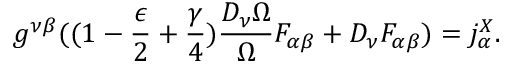Convert formula to latex. <formula><loc_0><loc_0><loc_500><loc_500>g ^ { \nu \beta } ( ( 1 - \frac { \epsilon } { 2 } + \frac { \gamma } { 4 } ) \frac { D _ { \nu } \Omega } { \Omega } F _ { \alpha \beta } + D _ { \nu } F _ { \alpha \beta } ) = j _ { \alpha } ^ { X } .</formula> 